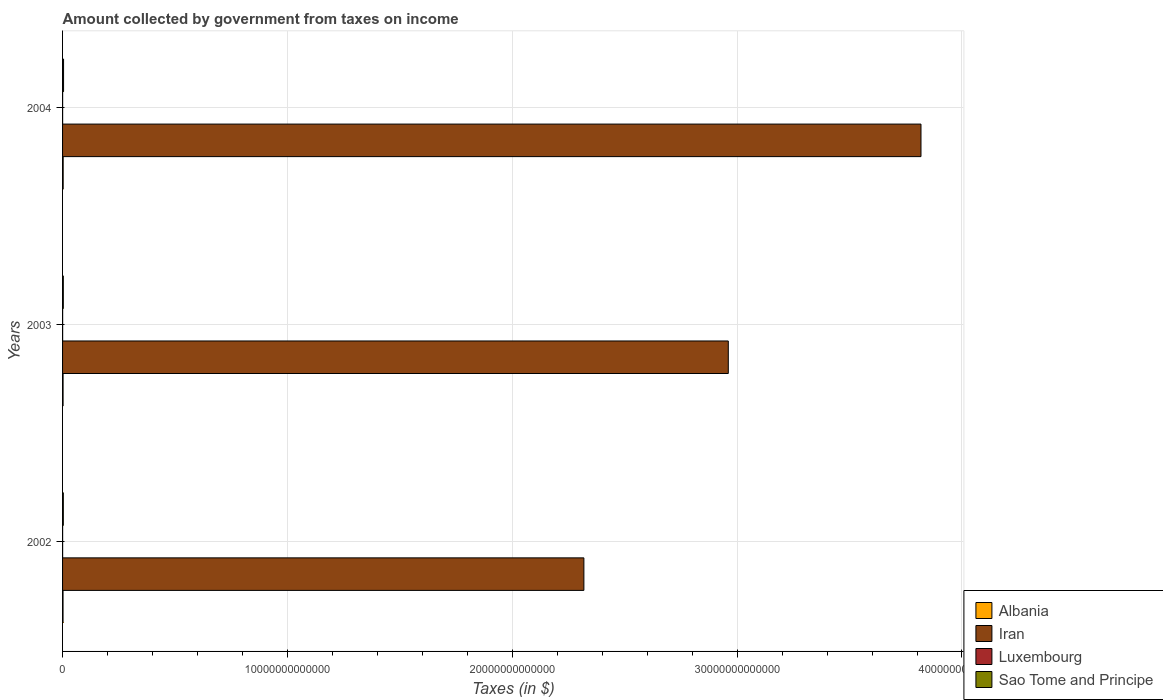How many different coloured bars are there?
Your answer should be very brief. 4. How many groups of bars are there?
Your response must be concise. 3. Are the number of bars on each tick of the Y-axis equal?
Your answer should be compact. Yes. What is the label of the 2nd group of bars from the top?
Offer a very short reply. 2003. In how many cases, is the number of bars for a given year not equal to the number of legend labels?
Keep it short and to the point. 0. What is the amount collected by government from taxes on income in Sao Tome and Principe in 2003?
Your answer should be very brief. 3.30e+1. Across all years, what is the maximum amount collected by government from taxes on income in Luxembourg?
Offer a terse response. 3.03e+09. Across all years, what is the minimum amount collected by government from taxes on income in Sao Tome and Principe?
Your answer should be compact. 3.30e+1. In which year was the amount collected by government from taxes on income in Iran maximum?
Your answer should be very brief. 2004. What is the total amount collected by government from taxes on income in Sao Tome and Principe in the graph?
Your response must be concise. 1.12e+11. What is the difference between the amount collected by government from taxes on income in Luxembourg in 2002 and that in 2004?
Keep it short and to the point. -1.84e+07. What is the difference between the amount collected by government from taxes on income in Albania in 2004 and the amount collected by government from taxes on income in Iran in 2002?
Keep it short and to the point. -2.32e+13. What is the average amount collected by government from taxes on income in Iran per year?
Your response must be concise. 3.03e+13. In the year 2003, what is the difference between the amount collected by government from taxes on income in Sao Tome and Principe and amount collected by government from taxes on income in Iran?
Provide a short and direct response. -2.96e+13. In how many years, is the amount collected by government from taxes on income in Iran greater than 24000000000000 $?
Provide a short and direct response. 2. What is the ratio of the amount collected by government from taxes on income in Sao Tome and Principe in 2003 to that in 2004?
Offer a terse response. 0.74. Is the amount collected by government from taxes on income in Luxembourg in 2002 less than that in 2003?
Your answer should be compact. Yes. What is the difference between the highest and the second highest amount collected by government from taxes on income in Albania?
Your answer should be very brief. 4.72e+09. What is the difference between the highest and the lowest amount collected by government from taxes on income in Albania?
Your response must be concise. 6.33e+09. In how many years, is the amount collected by government from taxes on income in Iran greater than the average amount collected by government from taxes on income in Iran taken over all years?
Provide a short and direct response. 1. Is the sum of the amount collected by government from taxes on income in Sao Tome and Principe in 2002 and 2004 greater than the maximum amount collected by government from taxes on income in Luxembourg across all years?
Provide a succinct answer. Yes. Is it the case that in every year, the sum of the amount collected by government from taxes on income in Albania and amount collected by government from taxes on income in Luxembourg is greater than the sum of amount collected by government from taxes on income in Sao Tome and Principe and amount collected by government from taxes on income in Iran?
Make the answer very short. No. What does the 3rd bar from the top in 2002 represents?
Offer a terse response. Iran. What does the 1st bar from the bottom in 2003 represents?
Your answer should be very brief. Albania. How many bars are there?
Provide a short and direct response. 12. How many years are there in the graph?
Give a very brief answer. 3. What is the difference between two consecutive major ticks on the X-axis?
Keep it short and to the point. 1.00e+13. How are the legend labels stacked?
Your answer should be very brief. Vertical. What is the title of the graph?
Your answer should be very brief. Amount collected by government from taxes on income. What is the label or title of the X-axis?
Keep it short and to the point. Taxes (in $). What is the label or title of the Y-axis?
Offer a terse response. Years. What is the Taxes (in $) in Albania in 2002?
Provide a succinct answer. 2.09e+1. What is the Taxes (in $) in Iran in 2002?
Your answer should be compact. 2.32e+13. What is the Taxes (in $) in Luxembourg in 2002?
Offer a terse response. 2.92e+09. What is the Taxes (in $) in Sao Tome and Principe in 2002?
Your answer should be compact. 3.41e+1. What is the Taxes (in $) of Albania in 2003?
Your answer should be compact. 2.25e+1. What is the Taxes (in $) in Iran in 2003?
Give a very brief answer. 2.96e+13. What is the Taxes (in $) of Luxembourg in 2003?
Your answer should be compact. 3.03e+09. What is the Taxes (in $) in Sao Tome and Principe in 2003?
Offer a very short reply. 3.30e+1. What is the Taxes (in $) in Albania in 2004?
Keep it short and to the point. 2.72e+1. What is the Taxes (in $) in Iran in 2004?
Provide a succinct answer. 3.82e+13. What is the Taxes (in $) of Luxembourg in 2004?
Make the answer very short. 2.94e+09. What is the Taxes (in $) in Sao Tome and Principe in 2004?
Provide a succinct answer. 4.45e+1. Across all years, what is the maximum Taxes (in $) in Albania?
Ensure brevity in your answer.  2.72e+1. Across all years, what is the maximum Taxes (in $) of Iran?
Give a very brief answer. 3.82e+13. Across all years, what is the maximum Taxes (in $) in Luxembourg?
Ensure brevity in your answer.  3.03e+09. Across all years, what is the maximum Taxes (in $) of Sao Tome and Principe?
Provide a short and direct response. 4.45e+1. Across all years, what is the minimum Taxes (in $) of Albania?
Keep it short and to the point. 2.09e+1. Across all years, what is the minimum Taxes (in $) of Iran?
Offer a terse response. 2.32e+13. Across all years, what is the minimum Taxes (in $) of Luxembourg?
Your answer should be very brief. 2.92e+09. Across all years, what is the minimum Taxes (in $) of Sao Tome and Principe?
Provide a short and direct response. 3.30e+1. What is the total Taxes (in $) of Albania in the graph?
Provide a short and direct response. 7.06e+1. What is the total Taxes (in $) of Iran in the graph?
Ensure brevity in your answer.  9.10e+13. What is the total Taxes (in $) in Luxembourg in the graph?
Make the answer very short. 8.89e+09. What is the total Taxes (in $) of Sao Tome and Principe in the graph?
Offer a very short reply. 1.12e+11. What is the difference between the Taxes (in $) in Albania in 2002 and that in 2003?
Give a very brief answer. -1.61e+09. What is the difference between the Taxes (in $) of Iran in 2002 and that in 2003?
Your response must be concise. -6.42e+12. What is the difference between the Taxes (in $) in Luxembourg in 2002 and that in 2003?
Ensure brevity in your answer.  -1.15e+08. What is the difference between the Taxes (in $) of Sao Tome and Principe in 2002 and that in 2003?
Your answer should be very brief. 1.13e+09. What is the difference between the Taxes (in $) in Albania in 2002 and that in 2004?
Ensure brevity in your answer.  -6.33e+09. What is the difference between the Taxes (in $) in Iran in 2002 and that in 2004?
Offer a terse response. -1.50e+13. What is the difference between the Taxes (in $) in Luxembourg in 2002 and that in 2004?
Provide a short and direct response. -1.84e+07. What is the difference between the Taxes (in $) in Sao Tome and Principe in 2002 and that in 2004?
Your answer should be compact. -1.04e+1. What is the difference between the Taxes (in $) of Albania in 2003 and that in 2004?
Provide a succinct answer. -4.72e+09. What is the difference between the Taxes (in $) of Iran in 2003 and that in 2004?
Offer a very short reply. -8.57e+12. What is the difference between the Taxes (in $) of Luxembourg in 2003 and that in 2004?
Give a very brief answer. 9.69e+07. What is the difference between the Taxes (in $) in Sao Tome and Principe in 2003 and that in 2004?
Offer a very short reply. -1.15e+1. What is the difference between the Taxes (in $) of Albania in 2002 and the Taxes (in $) of Iran in 2003?
Provide a succinct answer. -2.96e+13. What is the difference between the Taxes (in $) in Albania in 2002 and the Taxes (in $) in Luxembourg in 2003?
Offer a terse response. 1.79e+1. What is the difference between the Taxes (in $) of Albania in 2002 and the Taxes (in $) of Sao Tome and Principe in 2003?
Offer a very short reply. -1.21e+1. What is the difference between the Taxes (in $) of Iran in 2002 and the Taxes (in $) of Luxembourg in 2003?
Offer a terse response. 2.32e+13. What is the difference between the Taxes (in $) in Iran in 2002 and the Taxes (in $) in Sao Tome and Principe in 2003?
Ensure brevity in your answer.  2.32e+13. What is the difference between the Taxes (in $) in Luxembourg in 2002 and the Taxes (in $) in Sao Tome and Principe in 2003?
Provide a short and direct response. -3.00e+1. What is the difference between the Taxes (in $) of Albania in 2002 and the Taxes (in $) of Iran in 2004?
Your answer should be very brief. -3.82e+13. What is the difference between the Taxes (in $) in Albania in 2002 and the Taxes (in $) in Luxembourg in 2004?
Give a very brief answer. 1.80e+1. What is the difference between the Taxes (in $) in Albania in 2002 and the Taxes (in $) in Sao Tome and Principe in 2004?
Make the answer very short. -2.36e+1. What is the difference between the Taxes (in $) in Iran in 2002 and the Taxes (in $) in Luxembourg in 2004?
Ensure brevity in your answer.  2.32e+13. What is the difference between the Taxes (in $) of Iran in 2002 and the Taxes (in $) of Sao Tome and Principe in 2004?
Make the answer very short. 2.31e+13. What is the difference between the Taxes (in $) in Luxembourg in 2002 and the Taxes (in $) in Sao Tome and Principe in 2004?
Your answer should be compact. -4.16e+1. What is the difference between the Taxes (in $) of Albania in 2003 and the Taxes (in $) of Iran in 2004?
Make the answer very short. -3.82e+13. What is the difference between the Taxes (in $) in Albania in 2003 and the Taxes (in $) in Luxembourg in 2004?
Your answer should be very brief. 1.96e+1. What is the difference between the Taxes (in $) of Albania in 2003 and the Taxes (in $) of Sao Tome and Principe in 2004?
Offer a terse response. -2.20e+1. What is the difference between the Taxes (in $) of Iran in 2003 and the Taxes (in $) of Luxembourg in 2004?
Your response must be concise. 2.96e+13. What is the difference between the Taxes (in $) in Iran in 2003 and the Taxes (in $) in Sao Tome and Principe in 2004?
Make the answer very short. 2.96e+13. What is the difference between the Taxes (in $) in Luxembourg in 2003 and the Taxes (in $) in Sao Tome and Principe in 2004?
Keep it short and to the point. -4.15e+1. What is the average Taxes (in $) in Albania per year?
Provide a short and direct response. 2.35e+1. What is the average Taxes (in $) of Iran per year?
Provide a succinct answer. 3.03e+13. What is the average Taxes (in $) in Luxembourg per year?
Give a very brief answer. 2.96e+09. What is the average Taxes (in $) of Sao Tome and Principe per year?
Your answer should be compact. 3.72e+1. In the year 2002, what is the difference between the Taxes (in $) of Albania and Taxes (in $) of Iran?
Provide a short and direct response. -2.32e+13. In the year 2002, what is the difference between the Taxes (in $) in Albania and Taxes (in $) in Luxembourg?
Offer a very short reply. 1.80e+1. In the year 2002, what is the difference between the Taxes (in $) in Albania and Taxes (in $) in Sao Tome and Principe?
Give a very brief answer. -1.32e+1. In the year 2002, what is the difference between the Taxes (in $) in Iran and Taxes (in $) in Luxembourg?
Ensure brevity in your answer.  2.32e+13. In the year 2002, what is the difference between the Taxes (in $) in Iran and Taxes (in $) in Sao Tome and Principe?
Ensure brevity in your answer.  2.32e+13. In the year 2002, what is the difference between the Taxes (in $) in Luxembourg and Taxes (in $) in Sao Tome and Principe?
Offer a very short reply. -3.12e+1. In the year 2003, what is the difference between the Taxes (in $) in Albania and Taxes (in $) in Iran?
Offer a very short reply. -2.96e+13. In the year 2003, what is the difference between the Taxes (in $) of Albania and Taxes (in $) of Luxembourg?
Offer a terse response. 1.95e+1. In the year 2003, what is the difference between the Taxes (in $) of Albania and Taxes (in $) of Sao Tome and Principe?
Provide a short and direct response. -1.05e+1. In the year 2003, what is the difference between the Taxes (in $) in Iran and Taxes (in $) in Luxembourg?
Make the answer very short. 2.96e+13. In the year 2003, what is the difference between the Taxes (in $) in Iran and Taxes (in $) in Sao Tome and Principe?
Keep it short and to the point. 2.96e+13. In the year 2003, what is the difference between the Taxes (in $) in Luxembourg and Taxes (in $) in Sao Tome and Principe?
Your response must be concise. -2.99e+1. In the year 2004, what is the difference between the Taxes (in $) of Albania and Taxes (in $) of Iran?
Your response must be concise. -3.81e+13. In the year 2004, what is the difference between the Taxes (in $) in Albania and Taxes (in $) in Luxembourg?
Provide a short and direct response. 2.43e+1. In the year 2004, what is the difference between the Taxes (in $) of Albania and Taxes (in $) of Sao Tome and Principe?
Your response must be concise. -1.73e+1. In the year 2004, what is the difference between the Taxes (in $) in Iran and Taxes (in $) in Luxembourg?
Ensure brevity in your answer.  3.82e+13. In the year 2004, what is the difference between the Taxes (in $) of Iran and Taxes (in $) of Sao Tome and Principe?
Your answer should be compact. 3.81e+13. In the year 2004, what is the difference between the Taxes (in $) in Luxembourg and Taxes (in $) in Sao Tome and Principe?
Your answer should be compact. -4.15e+1. What is the ratio of the Taxes (in $) in Albania in 2002 to that in 2003?
Make the answer very short. 0.93. What is the ratio of the Taxes (in $) of Iran in 2002 to that in 2003?
Your answer should be compact. 0.78. What is the ratio of the Taxes (in $) in Sao Tome and Principe in 2002 to that in 2003?
Give a very brief answer. 1.03. What is the ratio of the Taxes (in $) of Albania in 2002 to that in 2004?
Provide a succinct answer. 0.77. What is the ratio of the Taxes (in $) in Iran in 2002 to that in 2004?
Your response must be concise. 0.61. What is the ratio of the Taxes (in $) in Luxembourg in 2002 to that in 2004?
Keep it short and to the point. 0.99. What is the ratio of the Taxes (in $) of Sao Tome and Principe in 2002 to that in 2004?
Offer a terse response. 0.77. What is the ratio of the Taxes (in $) in Albania in 2003 to that in 2004?
Your answer should be compact. 0.83. What is the ratio of the Taxes (in $) in Iran in 2003 to that in 2004?
Give a very brief answer. 0.78. What is the ratio of the Taxes (in $) in Luxembourg in 2003 to that in 2004?
Give a very brief answer. 1.03. What is the ratio of the Taxes (in $) in Sao Tome and Principe in 2003 to that in 2004?
Offer a very short reply. 0.74. What is the difference between the highest and the second highest Taxes (in $) in Albania?
Ensure brevity in your answer.  4.72e+09. What is the difference between the highest and the second highest Taxes (in $) of Iran?
Ensure brevity in your answer.  8.57e+12. What is the difference between the highest and the second highest Taxes (in $) in Luxembourg?
Offer a terse response. 9.69e+07. What is the difference between the highest and the second highest Taxes (in $) in Sao Tome and Principe?
Make the answer very short. 1.04e+1. What is the difference between the highest and the lowest Taxes (in $) in Albania?
Offer a terse response. 6.33e+09. What is the difference between the highest and the lowest Taxes (in $) in Iran?
Provide a succinct answer. 1.50e+13. What is the difference between the highest and the lowest Taxes (in $) in Luxembourg?
Offer a very short reply. 1.15e+08. What is the difference between the highest and the lowest Taxes (in $) of Sao Tome and Principe?
Provide a short and direct response. 1.15e+1. 